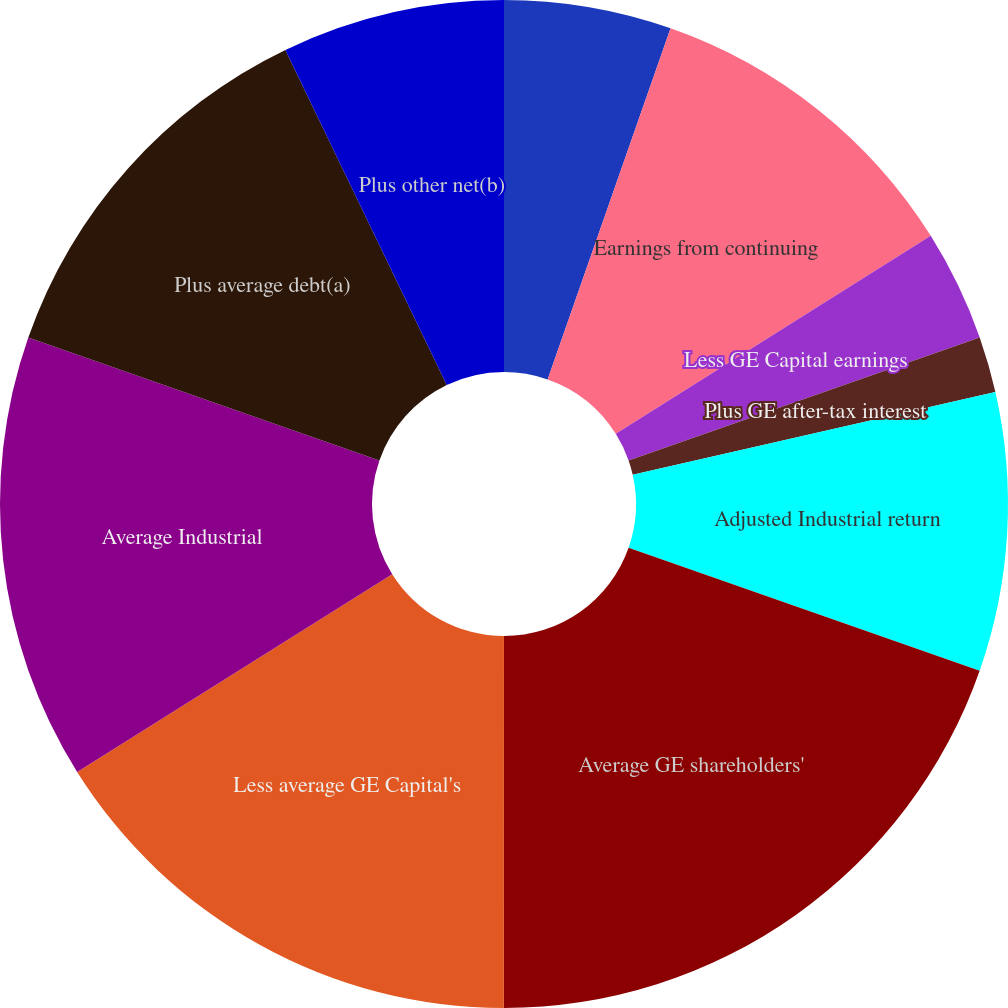Convert chart to OTSL. <chart><loc_0><loc_0><loc_500><loc_500><pie_chart><fcel>(Dollars in millions)<fcel>Earnings from continuing<fcel>Less GE Capital earnings<fcel>Plus GE after-tax interest<fcel>Adjusted Industrial return<fcel>Average GE shareholders'<fcel>Less average GE Capital's<fcel>Average Industrial<fcel>Plus average debt(a)<fcel>Plus other net(b)<nl><fcel>5.36%<fcel>10.71%<fcel>3.57%<fcel>1.79%<fcel>8.93%<fcel>19.64%<fcel>16.07%<fcel>14.28%<fcel>12.5%<fcel>7.14%<nl></chart> 